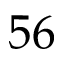<formula> <loc_0><loc_0><loc_500><loc_500>5 6</formula> 